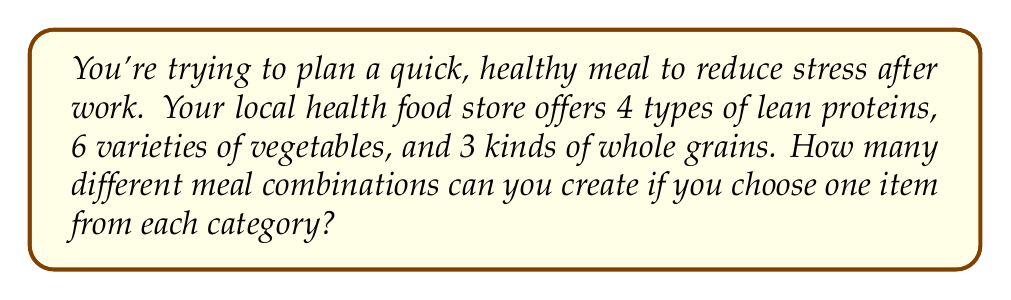Show me your answer to this math problem. Let's approach this step-by-step:

1) We are selecting one item from each of three categories: proteins, vegetables, and grains.

2) This is a perfect scenario for applying the multiplication principle of counting.

3) The multiplication principle states that if we have $m$ ways of doing something, $n$ ways of doing another thing, and $p$ ways of doing a third thing, then there are $m \times n \times p$ ways to do all three things.

4) In this case:
   - There are 4 choices for protein
   - There are 6 choices for vegetables
   - There are 3 choices for whole grains

5) Therefore, the total number of possible meal combinations is:

   $$ 4 \times 6 \times 3 = 72 $$

6) This means you can create 72 different meal combinations, giving you plenty of variety to help manage your stress through healthy eating.
Answer: 72 